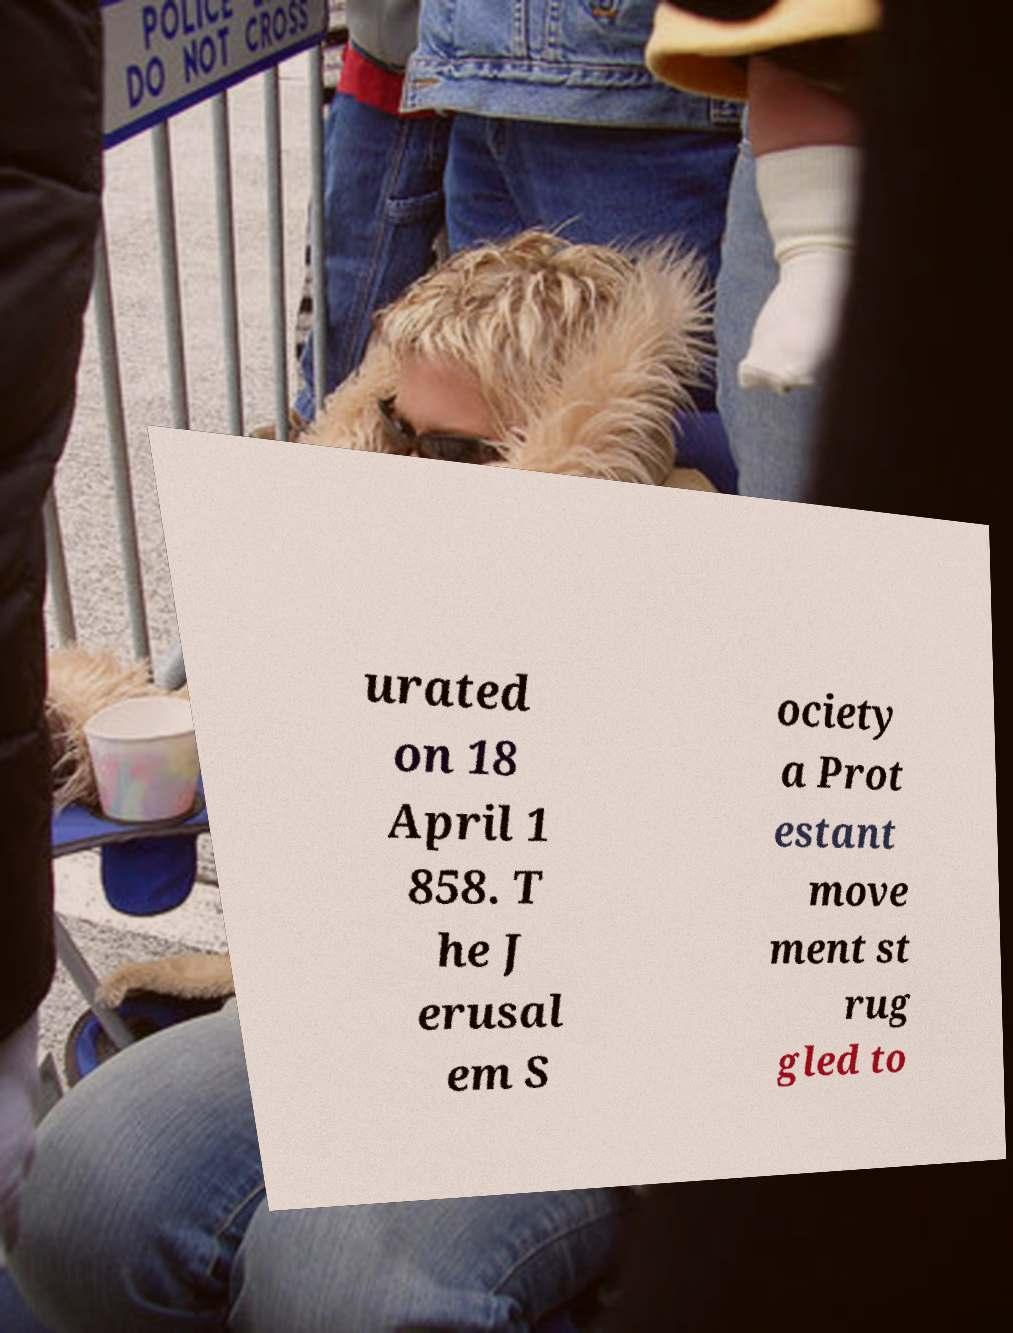Could you assist in decoding the text presented in this image and type it out clearly? urated on 18 April 1 858. T he J erusal em S ociety a Prot estant move ment st rug gled to 